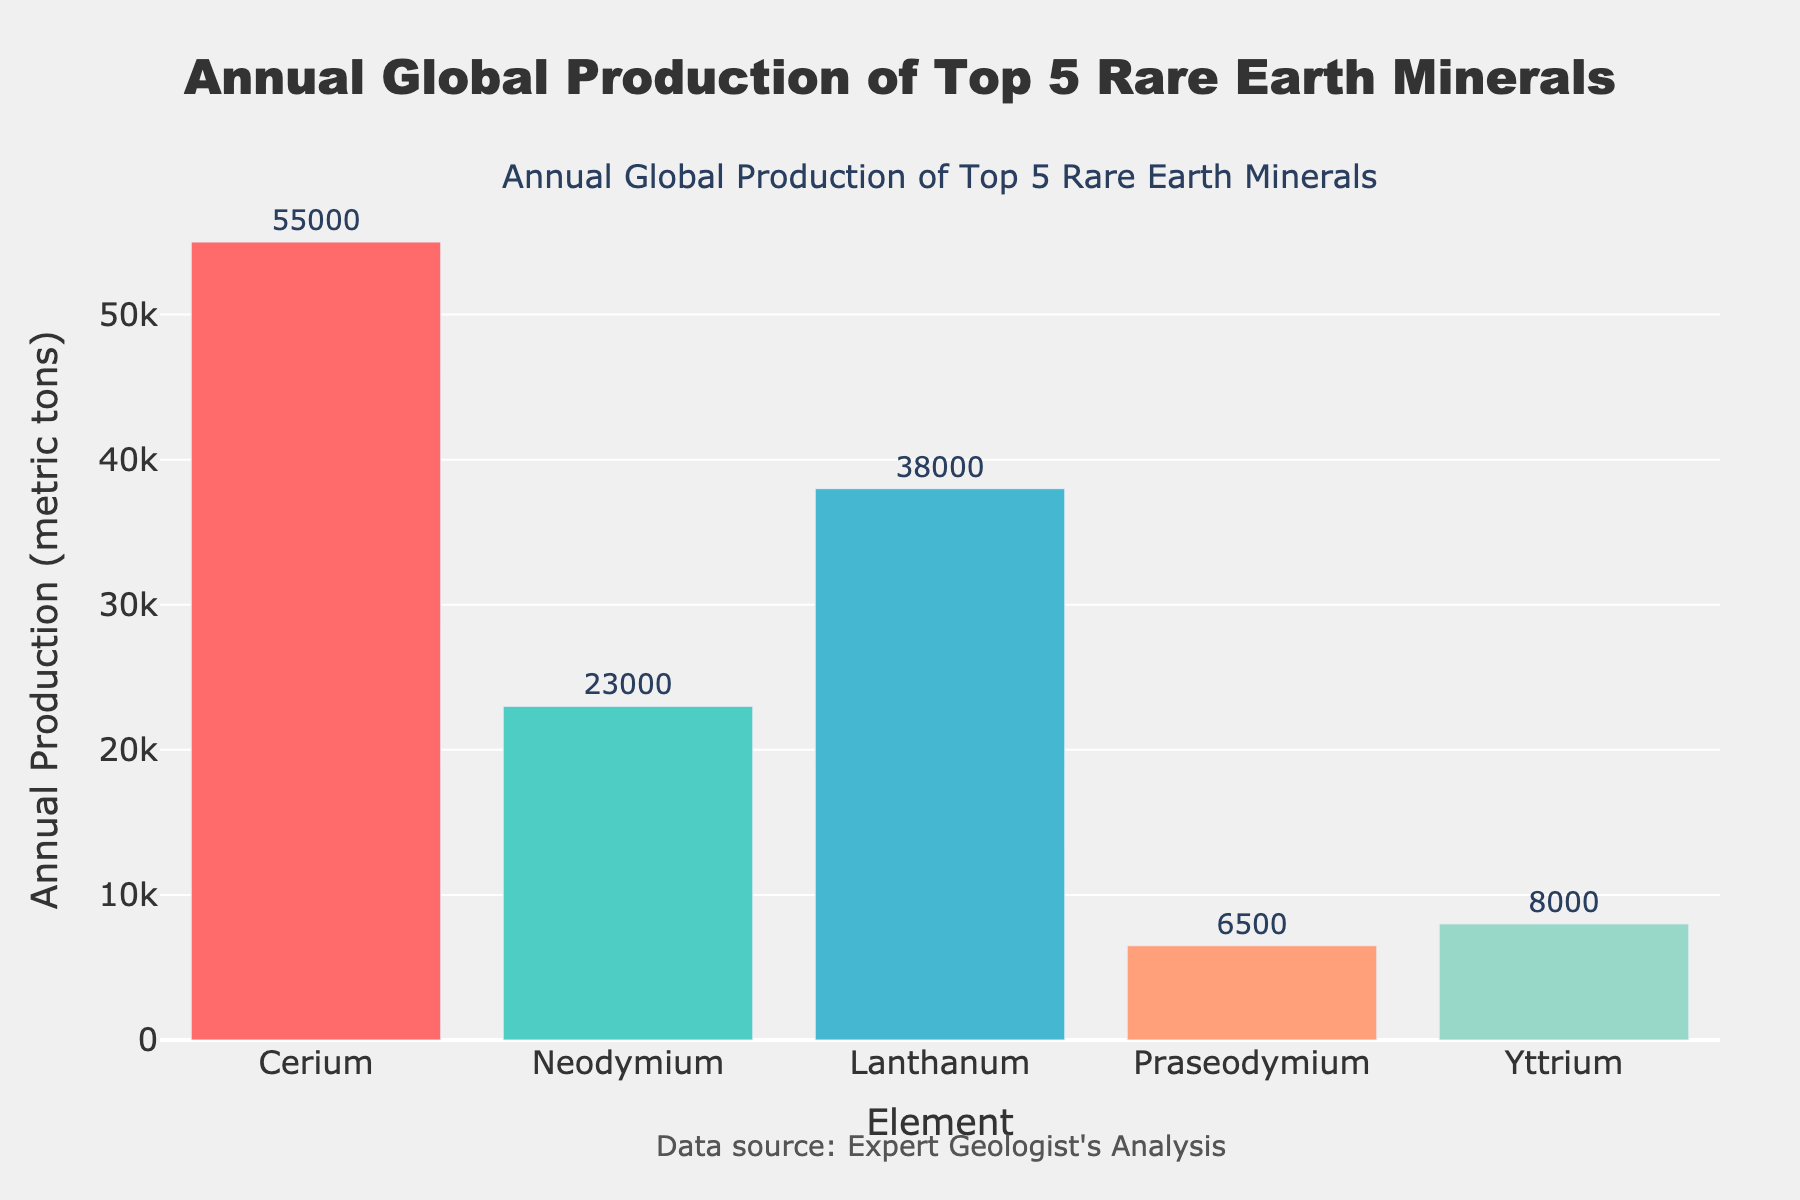Which element has the highest annual global production? From the bar heights, Cerium has the tallest bar, indicating it has the highest annual production.
Answer: Cerium What is the difference in annual production between Cerium and Neodymium? Cerium's production is 55,000 metric tons and Neodymium's is 23,000 metric tons. The difference is 55,000 - 23,000 = 32,000 metric tons.
Answer: 32,000 metric tons Which elements have an annual production greater than 20,000 metric tons? By comparing the bar heights, Cerium (55,000 metric tons), Neodymium (23,000 metric tons), and Lanthanum (38,000 metric tons) have annual productions greater than 20,000 metric tons.
Answer: Cerium, Neodymium, Lanthanum What is the total annual production of all five rare earth minerals combined? Add up the annual productions: 55,000 (Cerium) + 23,000 (Neodymium) + 38,000 (Lanthanum) + 6,500 (Praseodymium) + 8,000 (Yttrium) = 130,500 metric tons.
Answer: 130,500 metric tons What is the average annual production of the top 5 rare earth minerals? The total annual production is 130,500 metric tons. There are 5 elements, so the average is 130,500 / 5 = 26,100 metric tons.
Answer: 26,100 metric tons Which element has the smallest annual global production, and what is the value? The shortest bar belongs to Praseodymium, indicating it has the smallest annual production at 6,500 metric tons.
Answer: Praseodymium, 6,500 metric tons How much more annual production does Lanthanum have compared to Yttrium? Lanthanum's production is 38,000 metric tons and Yttrium's is 8,000 metric tons. The difference is 38,000 - 8,000 = 30,000 metric tons.
Answer: 30,000 metric tons What is the combined annual production of Praseodymium and Yttrium? Add up the annual productions: 6,500 (Praseodymium) + 8,000 (Yttrium) = 14,500 metric tons.
Answer: 14,500 metric tons What is the ratio of Cerium's annual production to the average annual production of all elements? Cerium’s production is 55,000 metric tons, and the average production is 26,100 metric tons. The ratio is 55,000 / 26,100 ≈ 2.11.
Answer: 2.11 If the combined production of Neodymium and Lanthanum was decreased by 10%, what would be the new combined production? Combined production is 23,000 (Neodymium) + 38,000 (Lanthanum) = 61,000 metric tons. Decreasing by 10%, the new value is 61,000 - (0.10 * 61,000) = 54,900 metric tons.
Answer: 54,900 metric tons 